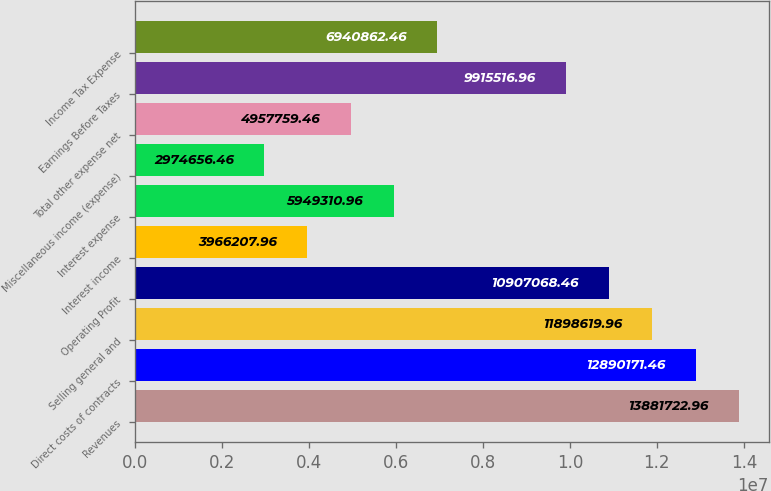Convert chart. <chart><loc_0><loc_0><loc_500><loc_500><bar_chart><fcel>Revenues<fcel>Direct costs of contracts<fcel>Selling general and<fcel>Operating Profit<fcel>Interest income<fcel>Interest expense<fcel>Miscellaneous income (expense)<fcel>Total other expense net<fcel>Earnings Before Taxes<fcel>Income Tax Expense<nl><fcel>1.38817e+07<fcel>1.28902e+07<fcel>1.18986e+07<fcel>1.09071e+07<fcel>3.96621e+06<fcel>5.94931e+06<fcel>2.97466e+06<fcel>4.95776e+06<fcel>9.91552e+06<fcel>6.94086e+06<nl></chart> 